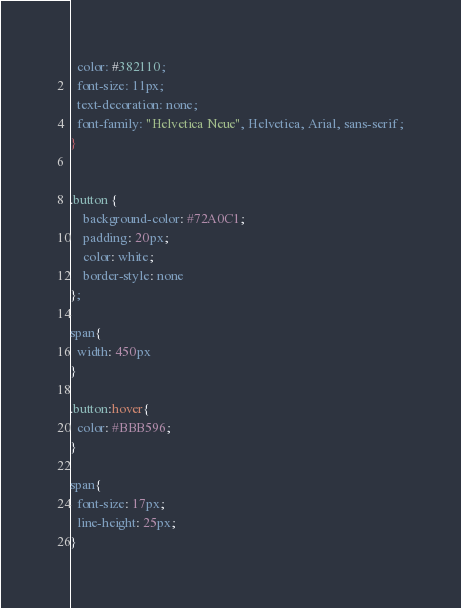Convert code to text. <code><loc_0><loc_0><loc_500><loc_500><_CSS_>  color: #382110;
  font-size: 11px;
  text-decoration: none;
  font-family: "Helvetica Neue", Helvetica, Arial, sans-serif;
}


.button {
    background-color: #72A0C1;
    padding: 20px;
    color: white;
    border-style: none
};

span{
  width: 450px
}

.button:hover{
  color: #BBB596;
}

span{
  font-size: 17px;
  line-height: 25px;
}
</code> 